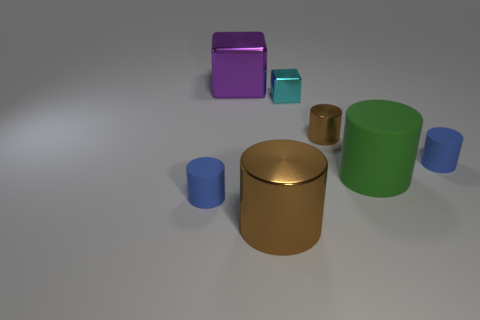Are there fewer big green objects to the left of the purple shiny object than purple metal objects behind the small brown cylinder?
Provide a succinct answer. Yes. Does the large metal cylinder have the same color as the tiny metallic cylinder?
Give a very brief answer. Yes. Is the number of things that are right of the green matte cylinder less than the number of tiny brown shiny cylinders?
Make the answer very short. No. What is the material of the small thing that is the same color as the large metal cylinder?
Offer a very short reply. Metal. Are the large block and the green thing made of the same material?
Make the answer very short. No. What number of brown cylinders are made of the same material as the small cyan thing?
Provide a short and direct response. 2. There is another tiny thing that is made of the same material as the small brown object; what color is it?
Your answer should be compact. Cyan. The green object has what shape?
Offer a very short reply. Cylinder. There is a blue cylinder that is behind the green cylinder; what is it made of?
Give a very brief answer. Rubber. Are there any big cylinders that have the same color as the tiny metallic cylinder?
Keep it short and to the point. Yes. 